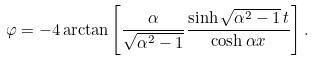<formula> <loc_0><loc_0><loc_500><loc_500>\varphi = - 4 \arctan \left [ \frac { \alpha } { \sqrt { \alpha ^ { 2 } - 1 } } \frac { \sinh \sqrt { \alpha ^ { 2 } - 1 } \, t } { \cosh \alpha x } \right ] .</formula> 